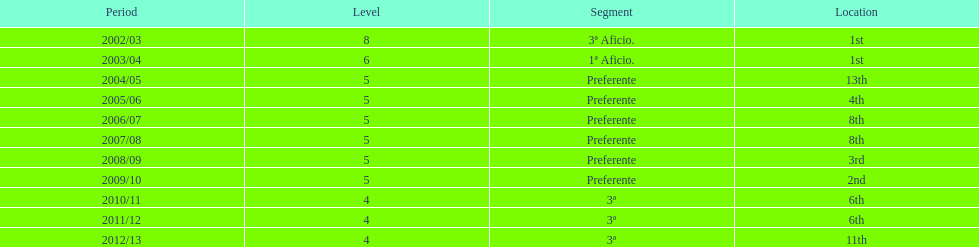How long did the team stay in first place? 2 years. 